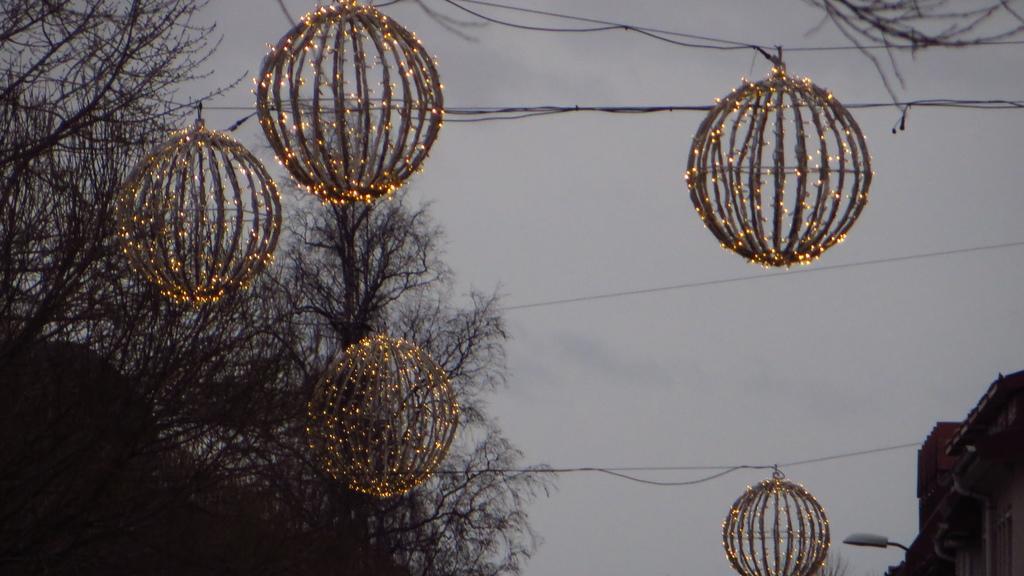Please provide a concise description of this image. In this picture, it seems like lanterns and wires in the foreground, there are trees, houses, pole and the sky in the background. 